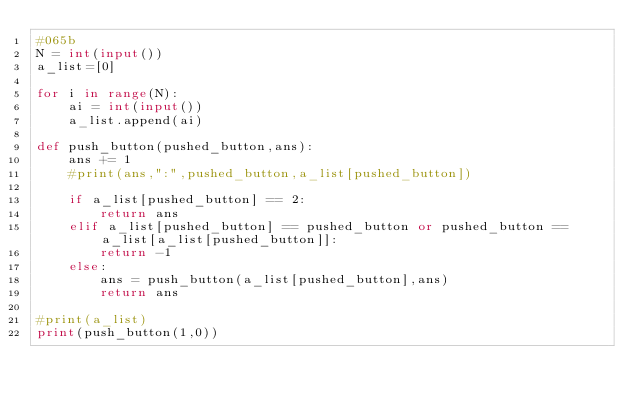<code> <loc_0><loc_0><loc_500><loc_500><_Python_>#065b
N = int(input())
a_list=[0]

for i in range(N):
    ai = int(input())
    a_list.append(ai)
    
def push_button(pushed_button,ans):
    ans += 1
    #print(ans,":",pushed_button,a_list[pushed_button])
    
    if a_list[pushed_button] == 2:
        return ans
    elif a_list[pushed_button] == pushed_button or pushed_button == a_list[a_list[pushed_button]]:
        return -1
    else:
        ans = push_button(a_list[pushed_button],ans)
        return ans
        
#print(a_list)
print(push_button(1,0))</code> 